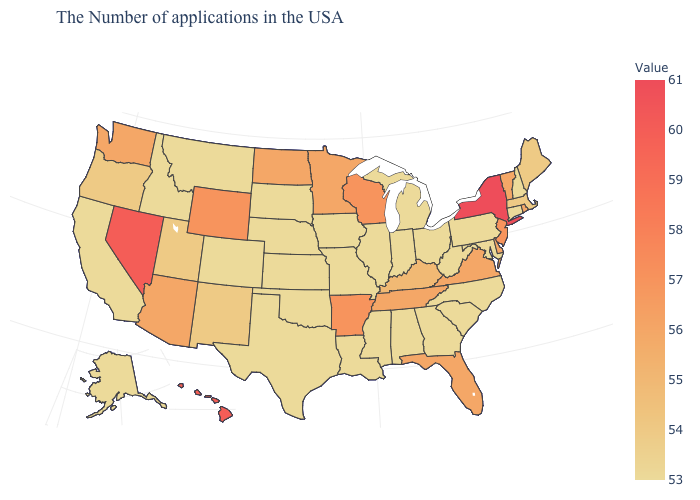Which states have the lowest value in the West?
Give a very brief answer. Colorado, Montana, Idaho, California, Alaska. Is the legend a continuous bar?
Give a very brief answer. Yes. Does New Hampshire have the highest value in the Northeast?
Concise answer only. No. Does Washington have the highest value in the West?
Keep it brief. No. Does Florida have the lowest value in the USA?
Write a very short answer. No. 